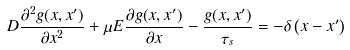Convert formula to latex. <formula><loc_0><loc_0><loc_500><loc_500>D \frac { \partial ^ { 2 } g ( x , x ^ { \prime } ) } { \partial x ^ { 2 } } + \mu E \frac { \partial g ( x , x ^ { \prime } ) } { \partial x } - \frac { g ( x , x ^ { \prime } ) } { \tau _ { s } } = - \delta \left ( x - x ^ { \prime } \right )</formula> 